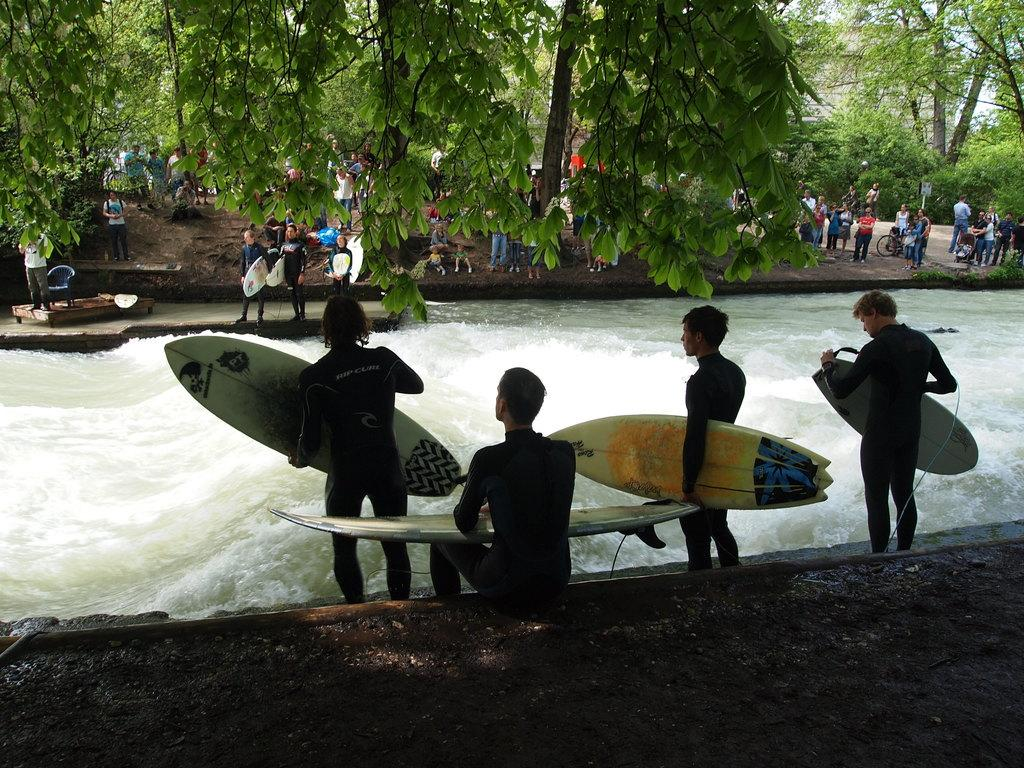What are the people in the image doing? Some of the people in the image are holding surfboards. What can be seen in the background of the image? There are trees in the image. What is the primary setting of the image? There is water visible in the image. What type of train can be seen in the image? There is no train present in the image. How many balls are visible in the image? There are no balls visible in the image. 